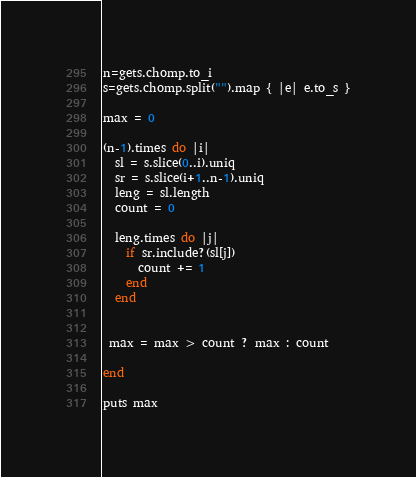Convert code to text. <code><loc_0><loc_0><loc_500><loc_500><_Ruby_>n=gets.chomp.to_i
s=gets.chomp.split("").map { |e| e.to_s }

max = 0

(n-1).times do |i|
  sl = s.slice(0..i).uniq
  sr = s.slice(i+1..n-1).uniq
  leng = sl.length
  count = 0

  leng.times do |j|
    if sr.include?(sl[j])
      count += 1
    end
  end


 max = max > count ? max : count

end

puts max
</code> 